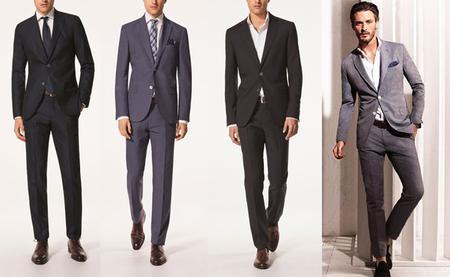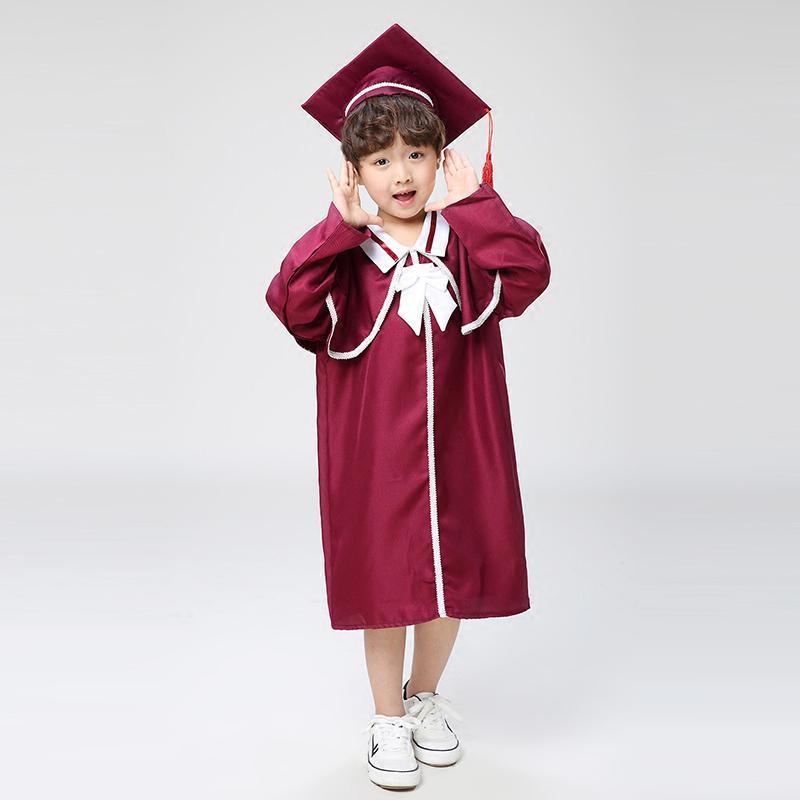The first image is the image on the left, the second image is the image on the right. Evaluate the accuracy of this statement regarding the images: "a single little girl in a red cap and gown". Is it true? Answer yes or no. Yes. The first image is the image on the left, the second image is the image on the right. Evaluate the accuracy of this statement regarding the images: "The people holding diplomas are not wearing glasses.". Is it true? Answer yes or no. No. 